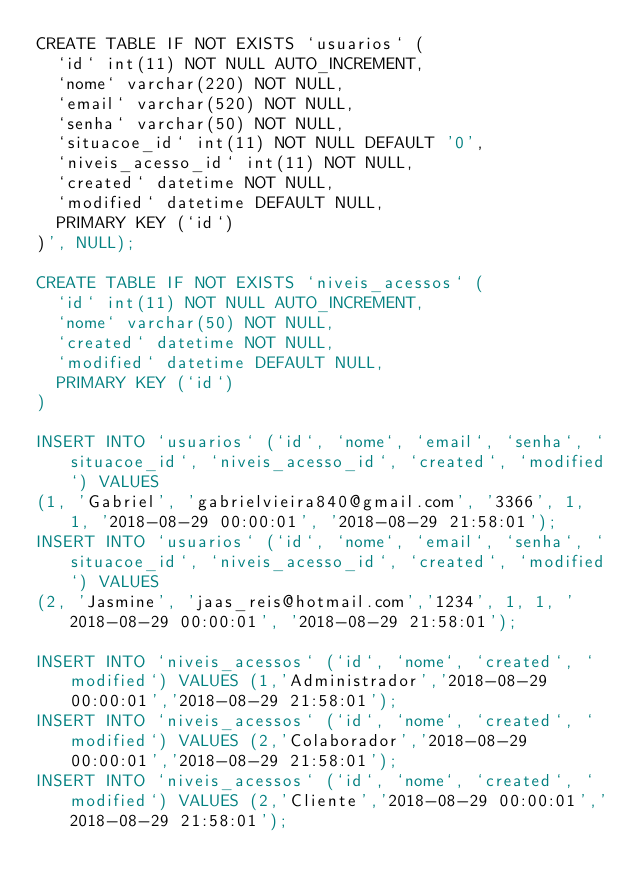Convert code to text. <code><loc_0><loc_0><loc_500><loc_500><_SQL_>CREATE TABLE IF NOT EXISTS `usuarios` (
  `id` int(11) NOT NULL AUTO_INCREMENT,
  `nome` varchar(220) NOT NULL,
  `email` varchar(520) NOT NULL,
  `senha` varchar(50) NOT NULL,
  `situacoe_id` int(11) NOT NULL DEFAULT '0',
  `niveis_acesso_id` int(11) NOT NULL,
  `created` datetime NOT NULL,
  `modified` datetime DEFAULT NULL,
  PRIMARY KEY (`id`)
)', NULL);

CREATE TABLE IF NOT EXISTS `niveis_acessos` (
  `id` int(11) NOT NULL AUTO_INCREMENT,
  `nome` varchar(50) NOT NULL,
  `created` datetime NOT NULL,
  `modified` datetime DEFAULT NULL,
  PRIMARY KEY (`id`)
)

INSERT INTO `usuarios` (`id`, `nome`, `email`, `senha`, `situacoe_id`, `niveis_acesso_id`, `created`, `modified`) VALUES
(1, 'Gabriel', 'gabrielvieira840@gmail.com', '3366', 1, 1, '2018-08-29 00:00:01', '2018-08-29 21:58:01');
INSERT INTO `usuarios` (`id`, `nome`, `email`, `senha`, `situacoe_id`, `niveis_acesso_id`, `created`, `modified`) VALUES
(2, 'Jasmine', 'jaas_reis@hotmail.com','1234', 1, 1, '2018-08-29 00:00:01', '2018-08-29 21:58:01');

INSERT INTO `niveis_acessos` (`id`, `nome`, `created`, `modified`) VALUES (1,'Administrador','2018-08-29 00:00:01','2018-08-29 21:58:01');
INSERT INTO `niveis_acessos` (`id`, `nome`, `created`, `modified`) VALUES (2,'Colaborador','2018-08-29 00:00:01','2018-08-29 21:58:01');
INSERT INTO `niveis_acessos` (`id`, `nome`, `created`, `modified`) VALUES (2,'Cliente','2018-08-29 00:00:01','2018-08-29 21:58:01');
</code> 